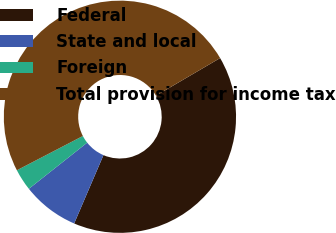Convert chart. <chart><loc_0><loc_0><loc_500><loc_500><pie_chart><fcel>Federal<fcel>State and local<fcel>Foreign<fcel>Total provision for income tax<nl><fcel>39.88%<fcel>7.9%<fcel>3.03%<fcel>49.19%<nl></chart> 